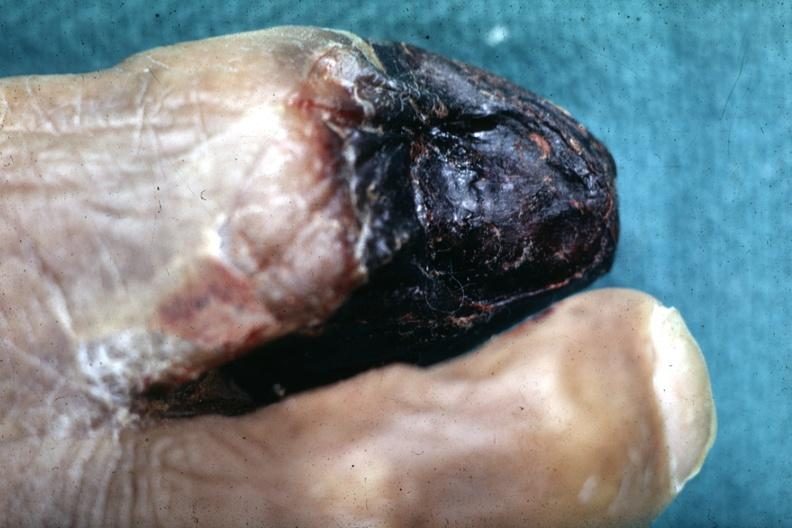does this image show close-up view of gangrene?
Answer the question using a single word or phrase. Yes 